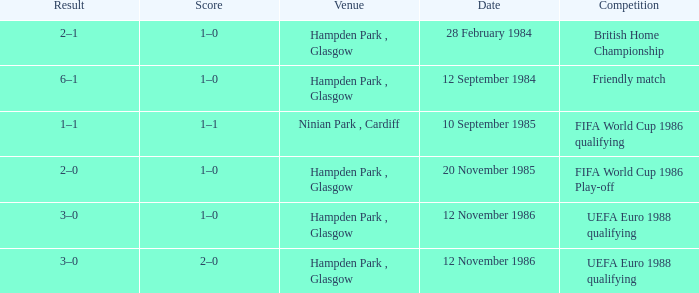What is the Score of the Fifa World Cup 1986 Play-off Competition? 1–0. 